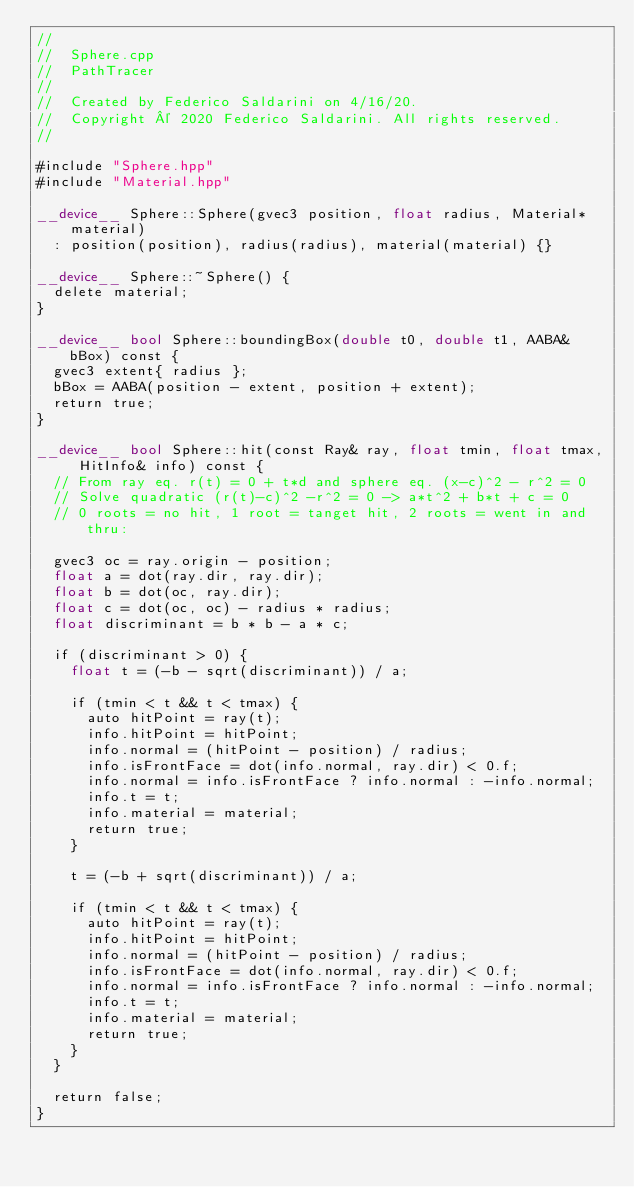Convert code to text. <code><loc_0><loc_0><loc_500><loc_500><_Cuda_>//
//  Sphere.cpp
//  PathTracer
//
//  Created by Federico Saldarini on 4/16/20.
//  Copyright © 2020 Federico Saldarini. All rights reserved.
//

#include "Sphere.hpp"
#include "Material.hpp"

__device__ Sphere::Sphere(gvec3 position, float radius, Material* material)
	: position(position), radius(radius), material(material) {}

__device__ Sphere::~Sphere() {
	delete material;
}

__device__ bool Sphere::boundingBox(double t0, double t1, AABA& bBox) const {
	gvec3 extent{ radius };
	bBox = AABA(position - extent, position + extent);
	return true;
}

__device__ bool Sphere::hit(const Ray& ray, float tmin, float tmax, HitInfo& info) const {
	// From ray eq. r(t) = 0 + t*d and sphere eq. (x-c)^2 - r^2 = 0
	// Solve quadratic (r(t)-c)^2 -r^2 = 0 -> a*t^2 + b*t + c = 0
	// 0 roots = no hit, 1 root = tanget hit, 2 roots = went in and thru:

	gvec3 oc = ray.origin - position;
	float a = dot(ray.dir, ray.dir);
	float b = dot(oc, ray.dir);
	float c = dot(oc, oc) - radius * radius;
	float discriminant = b * b - a * c;

	if (discriminant > 0) {
		float t = (-b - sqrt(discriminant)) / a;

		if (tmin < t && t < tmax) {
			auto hitPoint = ray(t);
			info.hitPoint = hitPoint;
			info.normal = (hitPoint - position) / radius;
			info.isFrontFace = dot(info.normal, ray.dir) < 0.f;
			info.normal = info.isFrontFace ? info.normal : -info.normal;
			info.t = t;
			info.material = material;
			return true;
		}

		t = (-b + sqrt(discriminant)) / a;

		if (tmin < t && t < tmax) {
			auto hitPoint = ray(t);
			info.hitPoint = hitPoint;
			info.normal = (hitPoint - position) / radius;
			info.isFrontFace = dot(info.normal, ray.dir) < 0.f;
			info.normal = info.isFrontFace ? info.normal : -info.normal;
			info.t = t;
			info.material = material;
			return true;
		}
	}

	return false;
}</code> 